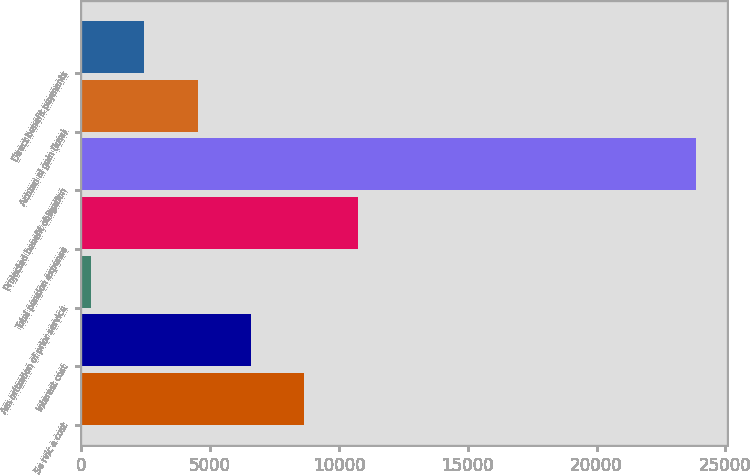<chart> <loc_0><loc_0><loc_500><loc_500><bar_chart><fcel>Se rvic e cost<fcel>Interest cost<fcel>Am ortization of prior service<fcel>Total pension expense<fcel>Projected benefit obligation<fcel>Actuari al gain (loss)<fcel>Direct benefit payments<nl><fcel>8658<fcel>6588<fcel>378<fcel>10728<fcel>23870<fcel>4518<fcel>2448<nl></chart> 